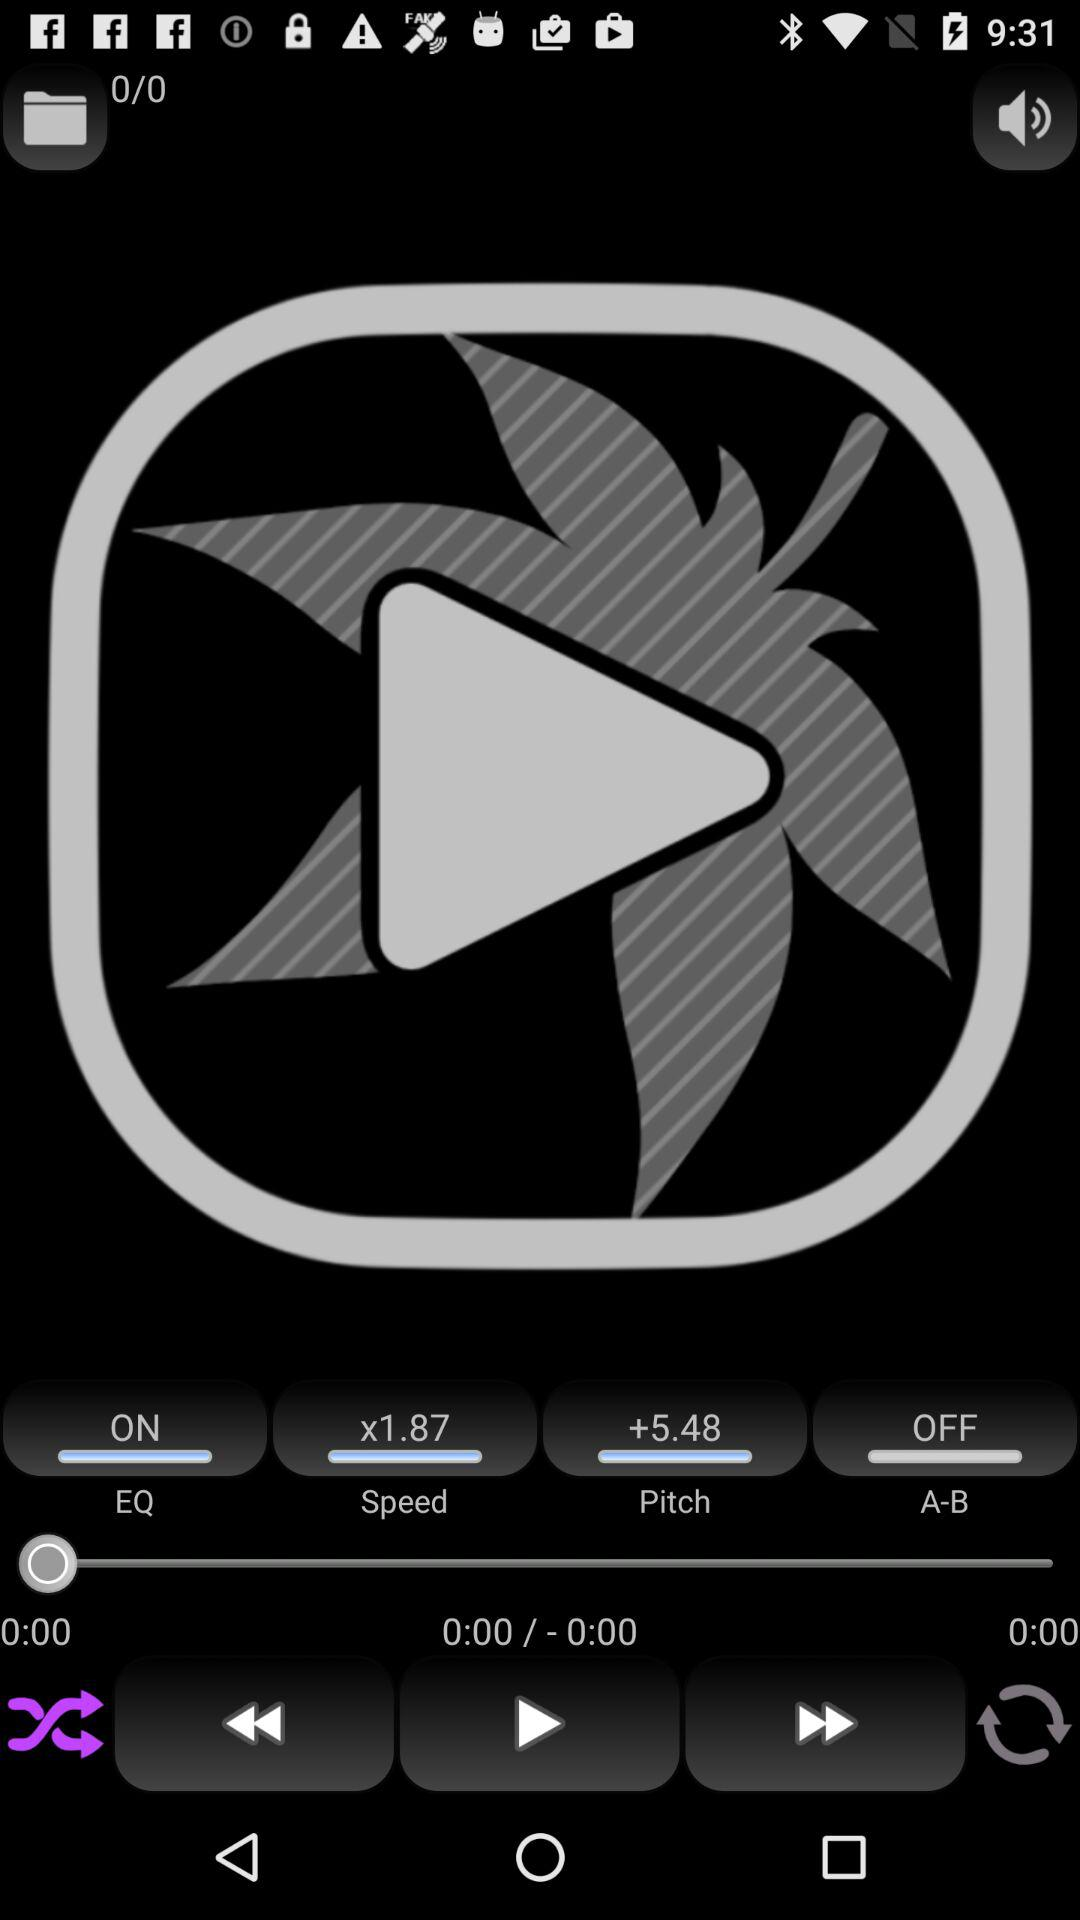What is the status of "EQ"? The status is "on". 